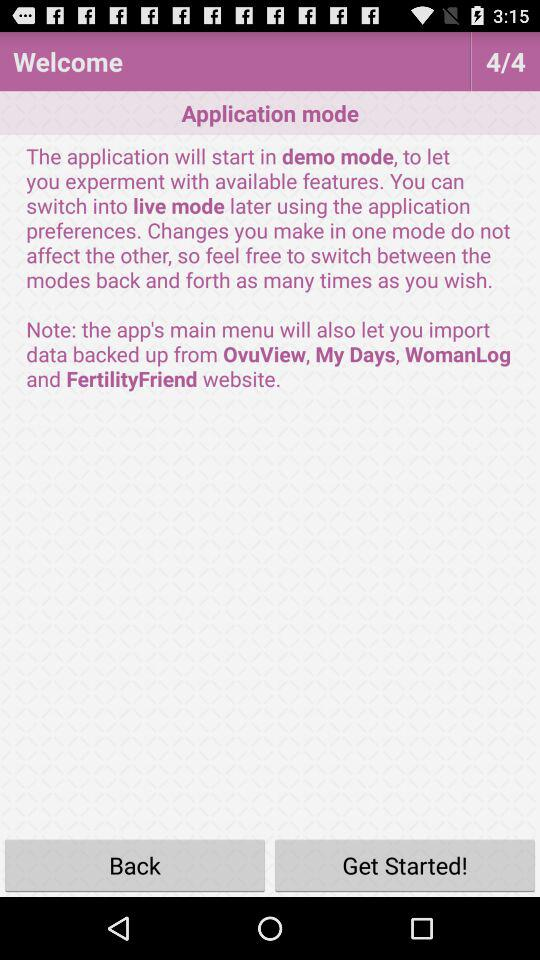How many total pages are there? There are four pages in total. 